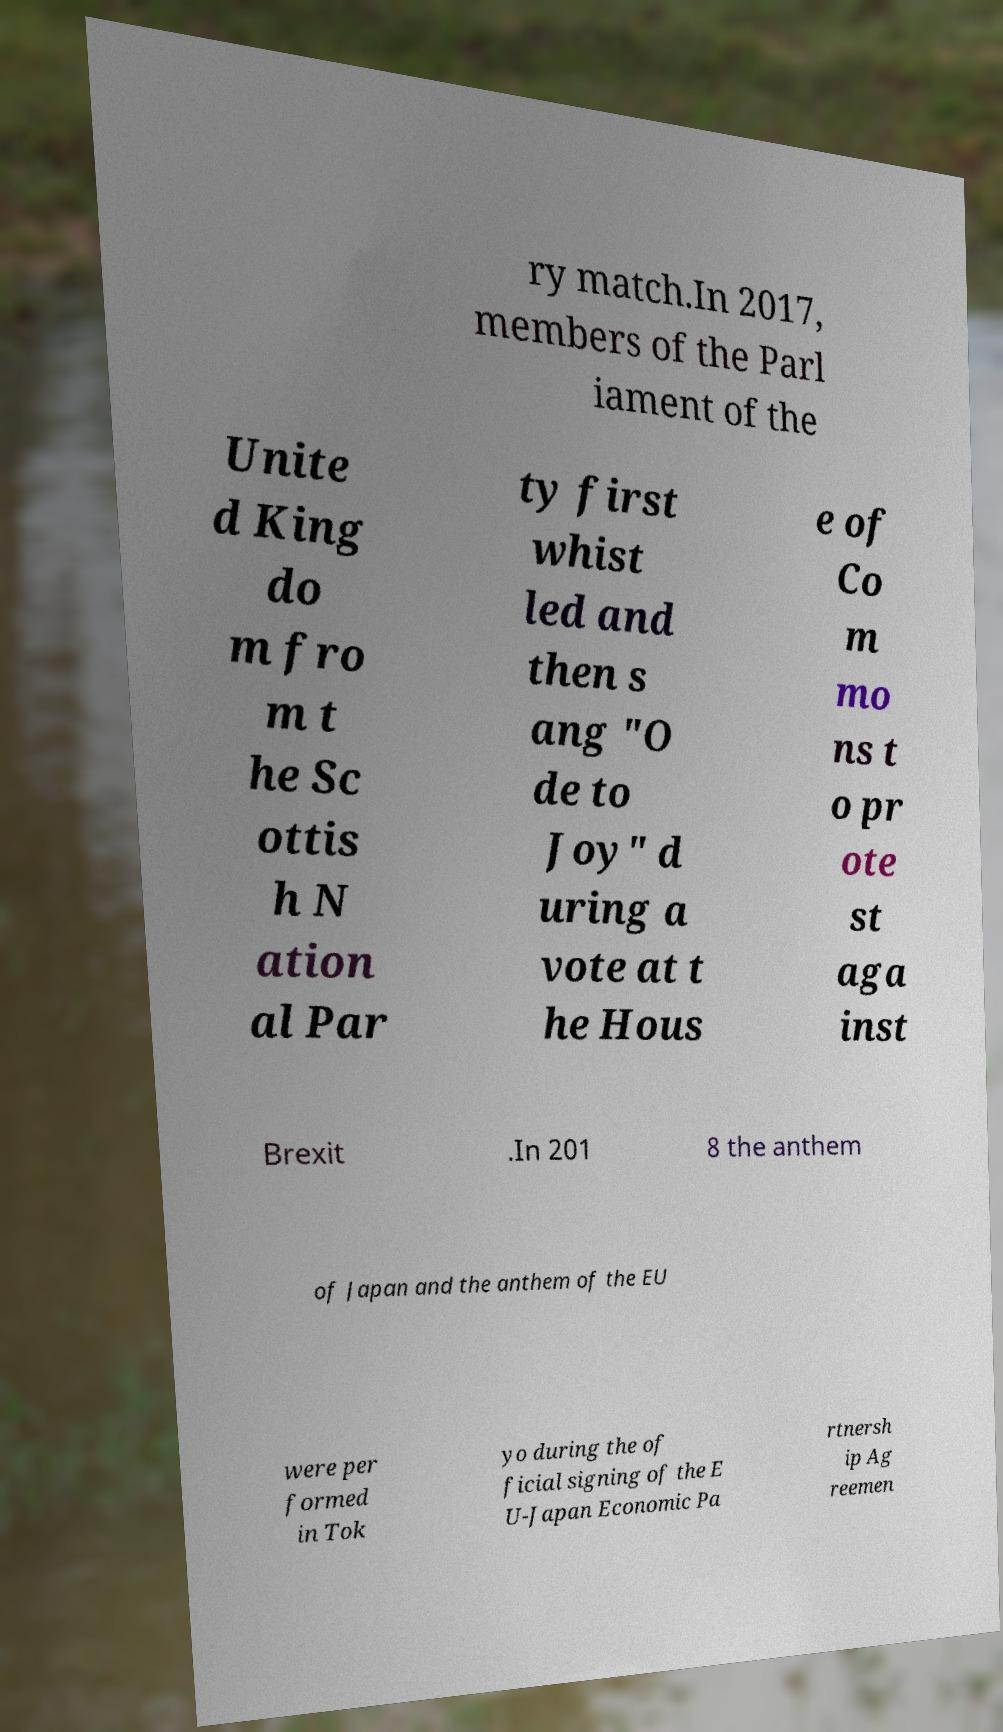I need the written content from this picture converted into text. Can you do that? ry match.In 2017, members of the Parl iament of the Unite d King do m fro m t he Sc ottis h N ation al Par ty first whist led and then s ang "O de to Joy" d uring a vote at t he Hous e of Co m mo ns t o pr ote st aga inst Brexit .In 201 8 the anthem of Japan and the anthem of the EU were per formed in Tok yo during the of ficial signing of the E U-Japan Economic Pa rtnersh ip Ag reemen 